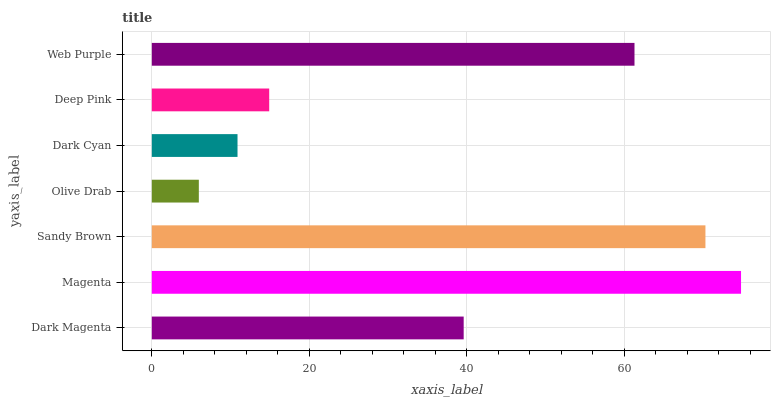Is Olive Drab the minimum?
Answer yes or no. Yes. Is Magenta the maximum?
Answer yes or no. Yes. Is Sandy Brown the minimum?
Answer yes or no. No. Is Sandy Brown the maximum?
Answer yes or no. No. Is Magenta greater than Sandy Brown?
Answer yes or no. Yes. Is Sandy Brown less than Magenta?
Answer yes or no. Yes. Is Sandy Brown greater than Magenta?
Answer yes or no. No. Is Magenta less than Sandy Brown?
Answer yes or no. No. Is Dark Magenta the high median?
Answer yes or no. Yes. Is Dark Magenta the low median?
Answer yes or no. Yes. Is Sandy Brown the high median?
Answer yes or no. No. Is Olive Drab the low median?
Answer yes or no. No. 